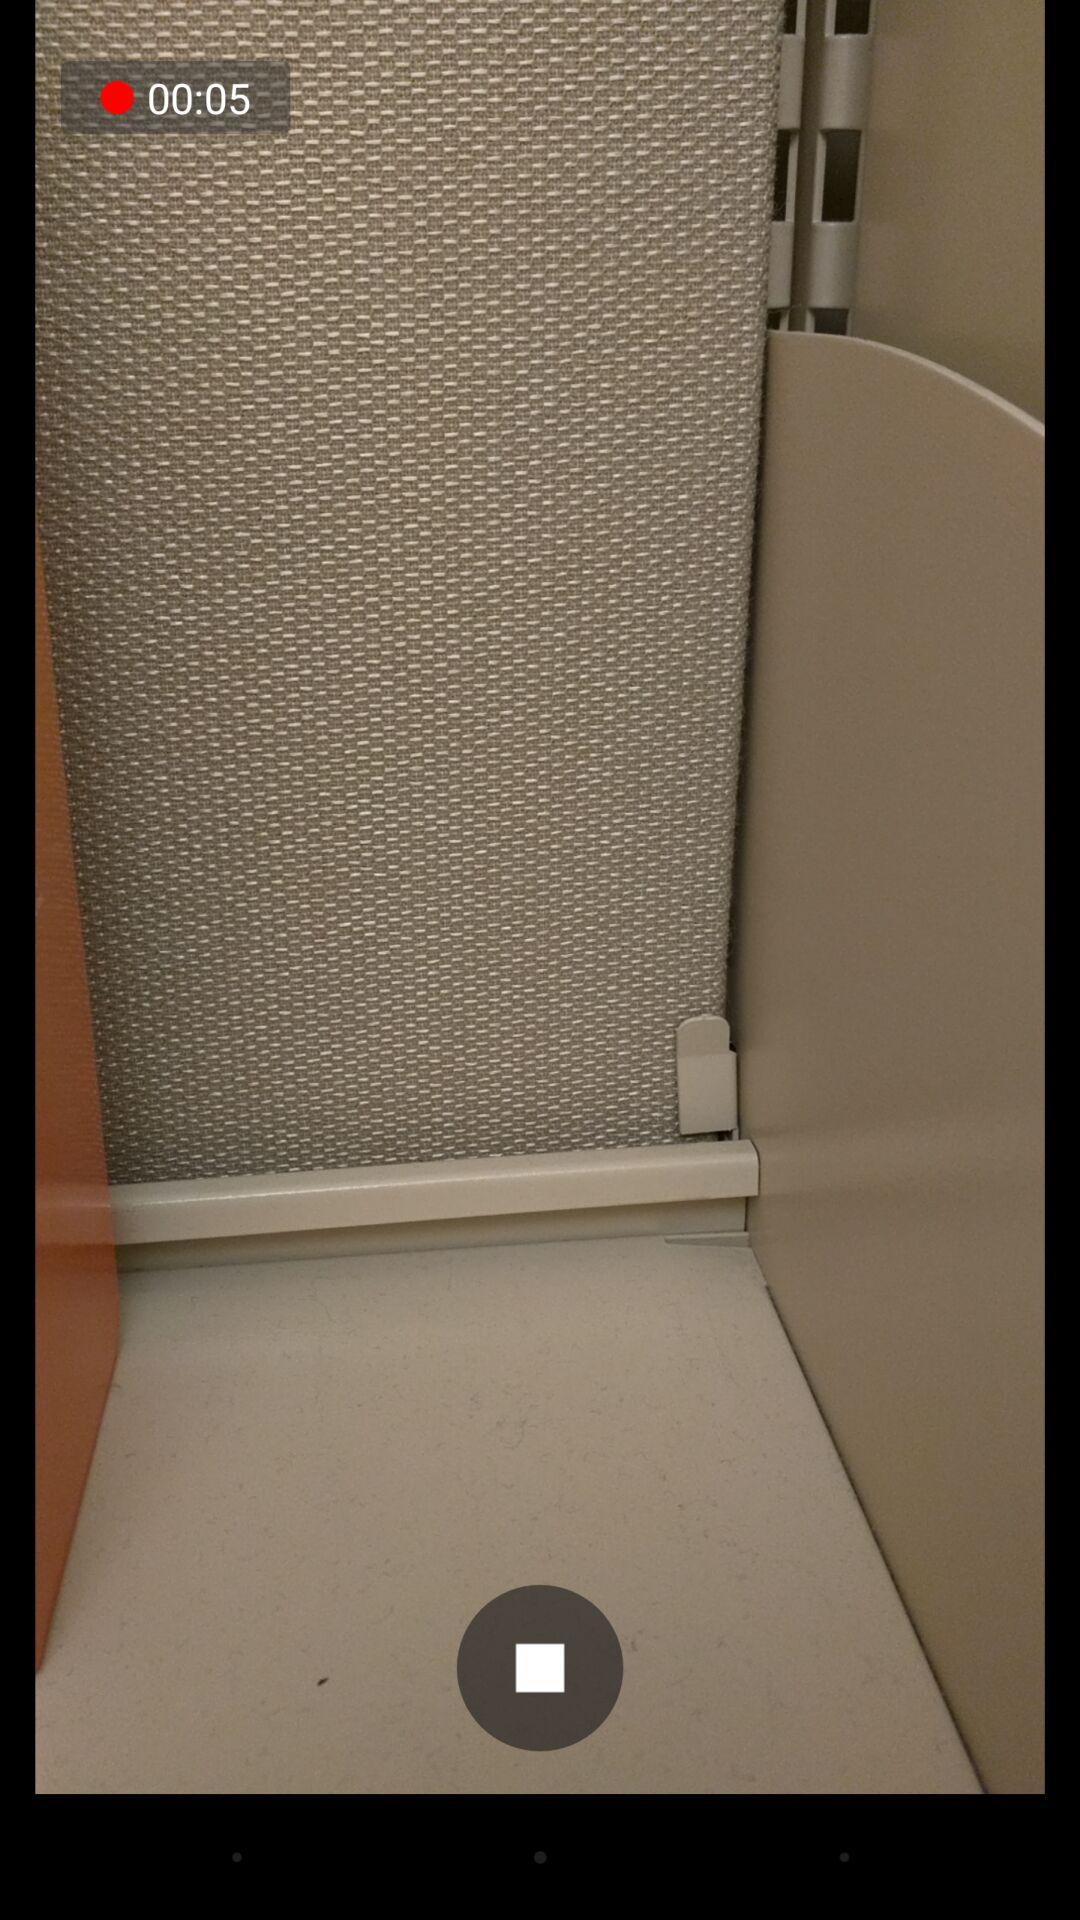How many seconds have passed since the video started?
Answer the question using a single word or phrase. 5 